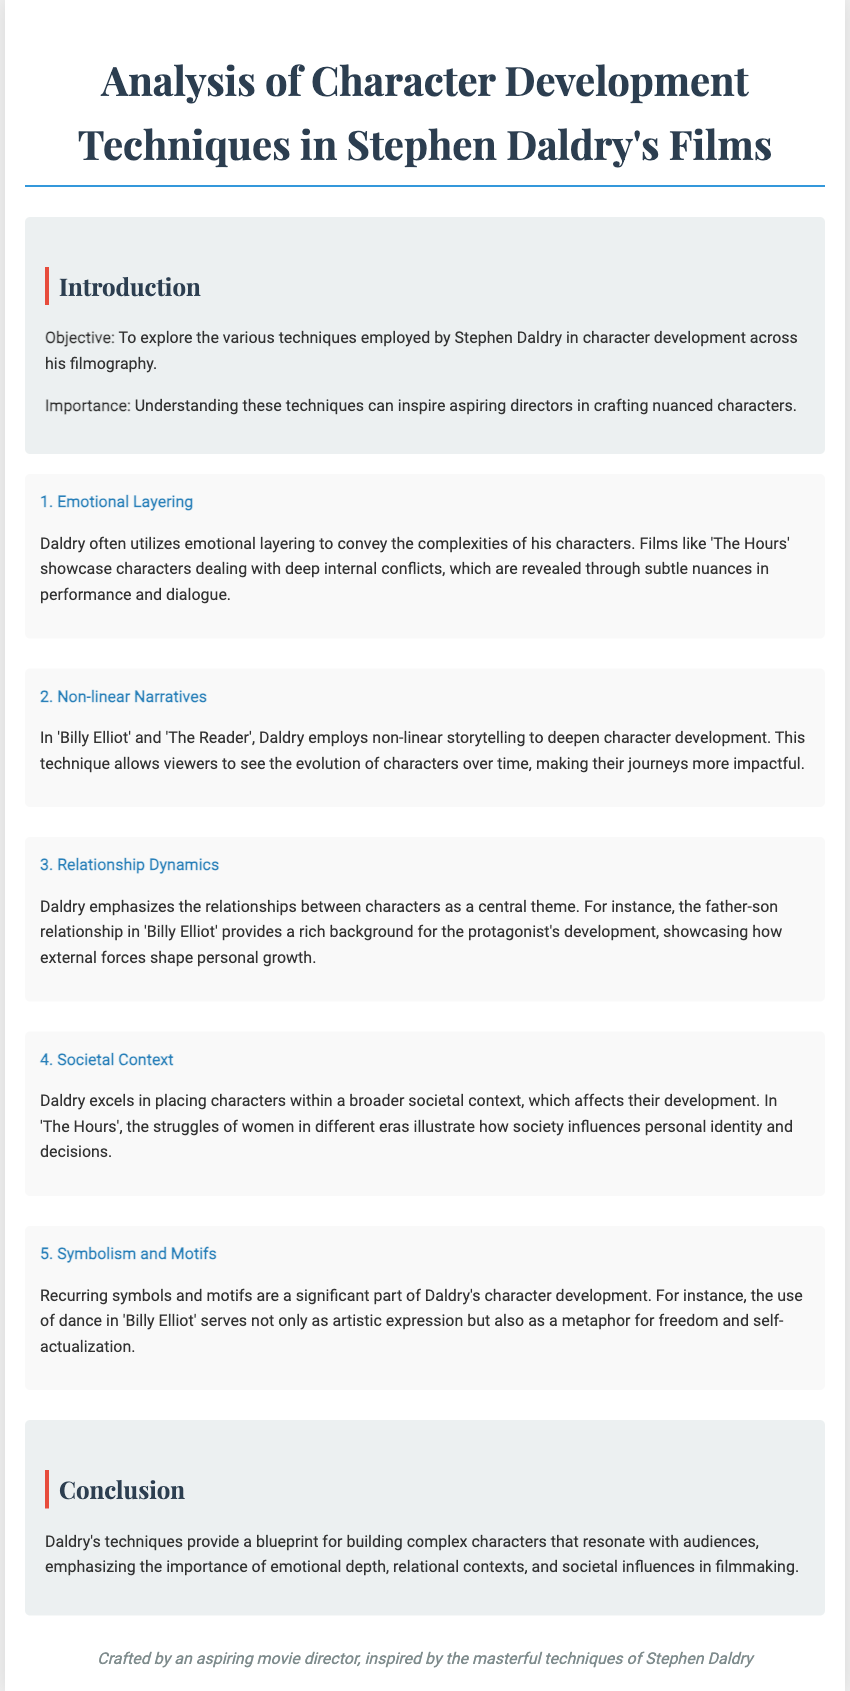What is the title of the document? The title, as stated prominently at the top of the document, is "Analysis of Character Development Techniques in Stephen Daldry's Films."
Answer: Analysis of Character Development Techniques in Stephen Daldry's Films What is the first character development technique mentioned? The first technique listed in the document is "Emotional Layering," which is described in the first section.
Answer: Emotional Layering How many character development techniques are discussed? The document discusses a total of five character development techniques.
Answer: Five Which film is mentioned in relation to non-linear narratives? The document references "Billy Elliot" and "The Reader" as films where non-linear narratives are employed.
Answer: Billy Elliot and The Reader What is highlighted as a central theme in Daldry's character development? The document emphasizes the importance of "Relationship Dynamics" as a central theme in character development.
Answer: Relationship Dynamics What broader context does Daldry place characters within? The document states that Daldry places characters within a "broader societal context," influencing their development.
Answer: Broader societal context What recurring elements are significant in Daldry's films? The document indicates that "Symbolism and Motifs" play a significant role in Daldry's character development techniques.
Answer: Symbolism and Motifs Which film uses dance as a metaphor for freedom? The document mentions that "Billy Elliot" uses dance as a metaphor for freedom and self-actualization.
Answer: Billy Elliot What is the concluding emphasis on Daldry's techniques? The conclusion underlines that Daldry's techniques provide a "blueprint for building complex characters."
Answer: Blueprint for building complex characters 